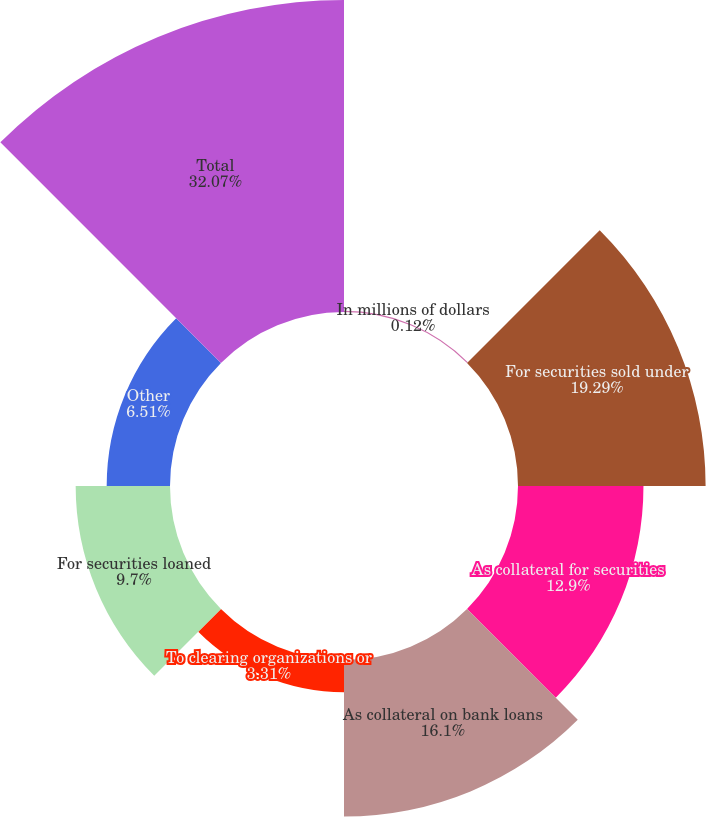Convert chart. <chart><loc_0><loc_0><loc_500><loc_500><pie_chart><fcel>In millions of dollars<fcel>For securities sold under<fcel>As collateral for securities<fcel>As collateral on bank loans<fcel>To clearing organizations or<fcel>For securities loaned<fcel>Other<fcel>Total<nl><fcel>0.12%<fcel>19.29%<fcel>12.9%<fcel>16.1%<fcel>3.31%<fcel>9.7%<fcel>6.51%<fcel>32.08%<nl></chart> 